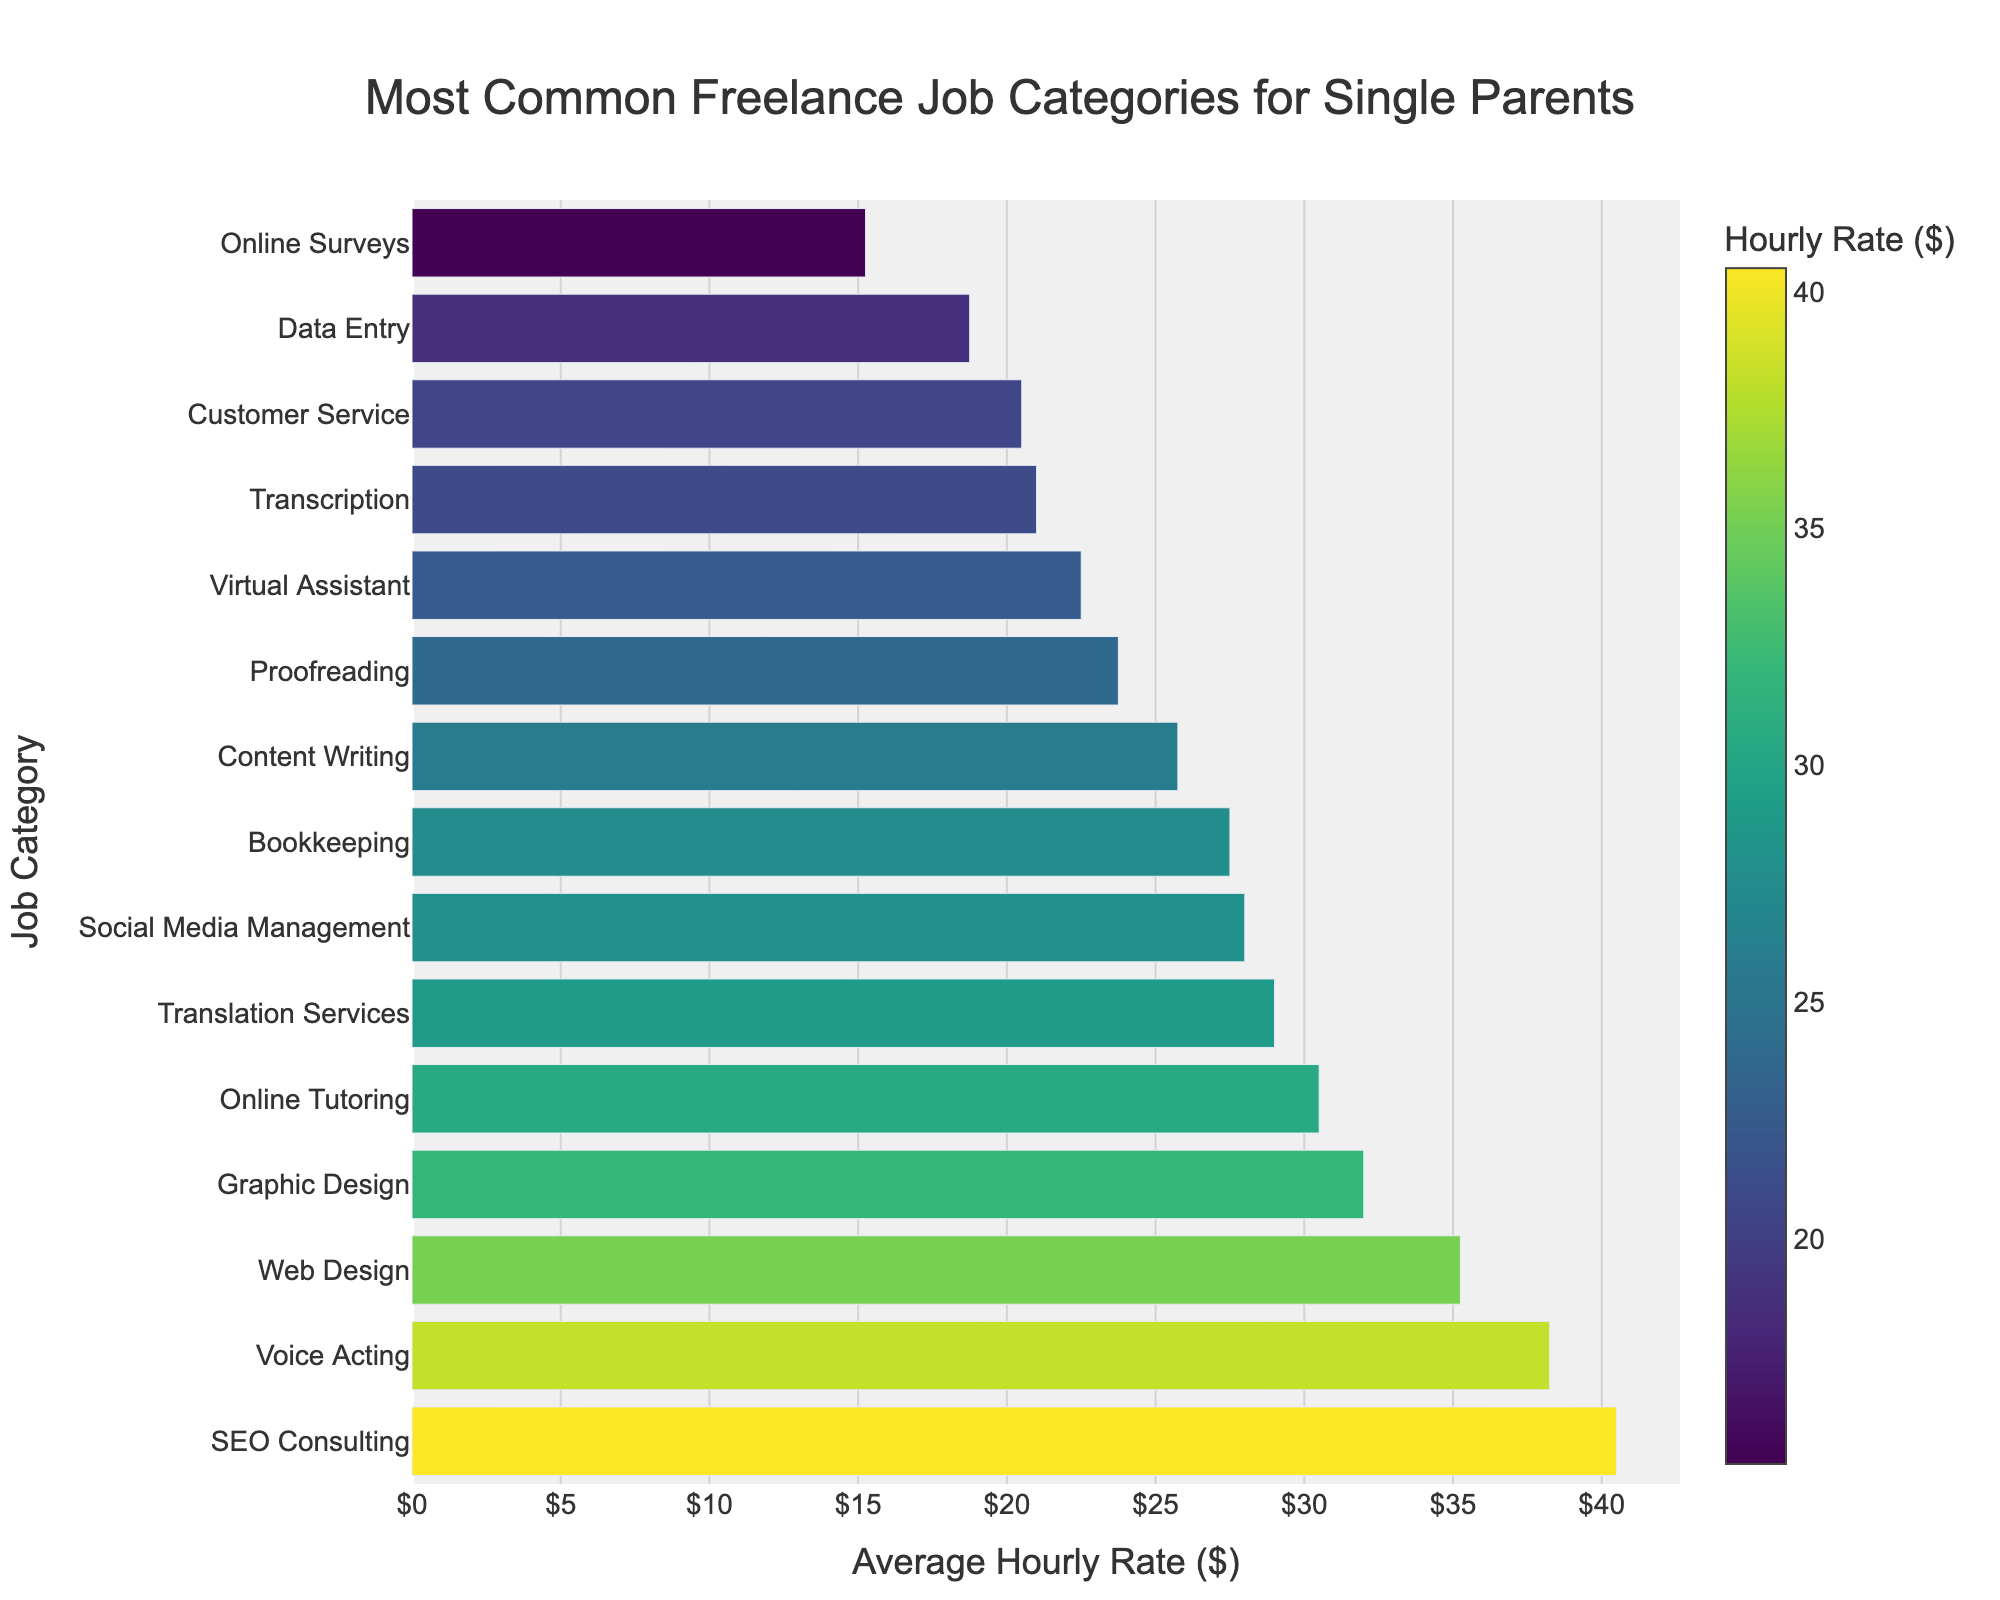Which job category has the highest average hourly rate? Look at the length of the bars. The longest bar corresponds to the category with the highest rate.
Answer: SEO Consulting What’s the difference in average hourly rate between Online Surveys and Online Tutoring? Identify the rates for both categories (Online Surveys: $15.25, Online Tutoring: $30.50) and subtract the smaller from the larger.
Answer: $15.25 Which job category earns more on average: Social Media Management or Bookkeeping? Compare the lengths of the bars for these categories. Social Media Management is $28.00, and Bookkeeping is $27.50.
Answer: Social Media Management What are the job categories with average hourly rates less than $20? Identify the bars that fall below the $20 mark. These are Data Entry ($18.75), Customer Service ($20.50 but slightly above), and Online Surveys ($15.25).
Answer: Data Entry, Online Surveys What is the average hourly rate for the jobs related to design (Graphic Design and Web Design)? Identify the rates for both categories (Graphic Design: $32.00, Web Design: $35.25). Calculate the average: (32.00 + 35.25) / 2.
Answer: $33.63 Which job has more average hourly rate: Proofreading or Virtual Assistant? Compare the lengths of the bars for these categories. Proofreading is $23.75, and Virtual Assistant is $22.50.
Answer: Proofreading Between Voice Acting and Translation Services, which one offers a higher average hourly rate and by how much? Identify the rates for both categories (Voice Acting: $38.25, Translation Services: $29.00). Subtract the smaller rate from the larger rate.
Answer: $9.25 Is there any job category with an average hourly rate around $30? Look for bars approximately at the $30 mark. Online Tutoring is $30.50, and Translation Services is close but not exact ($29.00).
Answer: Online Tutoring What is the difference in average hourly rate between the highest and lowest paying job categories? Identify the rates of the highest and lowest paying categories (SEO Consulting: $40.50, Online Surveys: $15.25). Subtract the smaller rate from the larger rate.
Answer: $25.25 